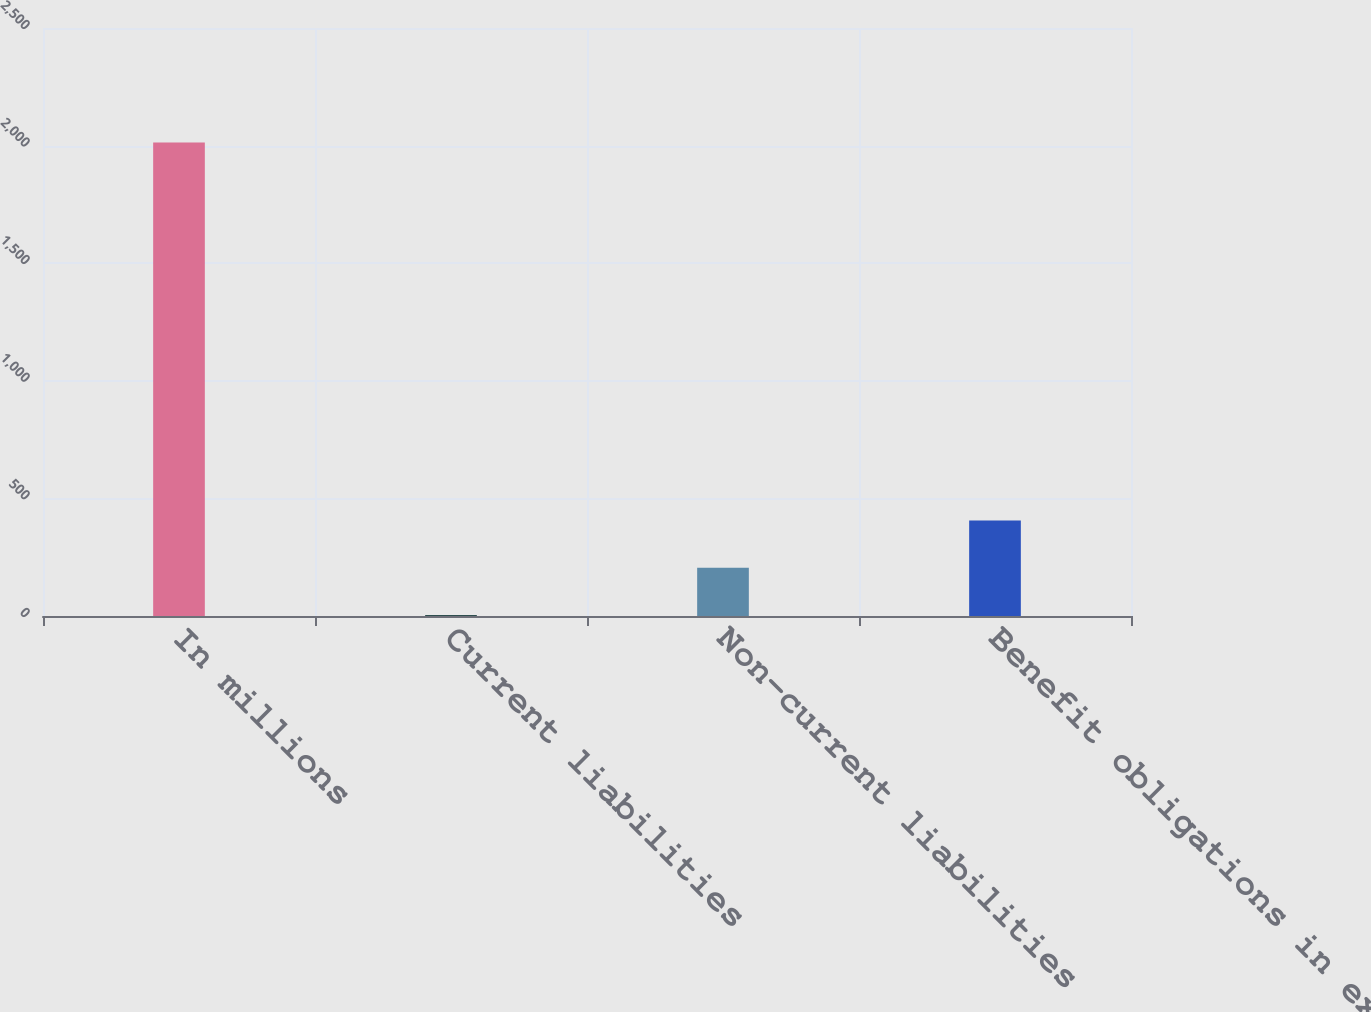Convert chart. <chart><loc_0><loc_0><loc_500><loc_500><bar_chart><fcel>In millions<fcel>Current liabilities<fcel>Non-current liabilities<fcel>Benefit obligations in excess<nl><fcel>2013<fcel>4.7<fcel>205.53<fcel>406.36<nl></chart> 